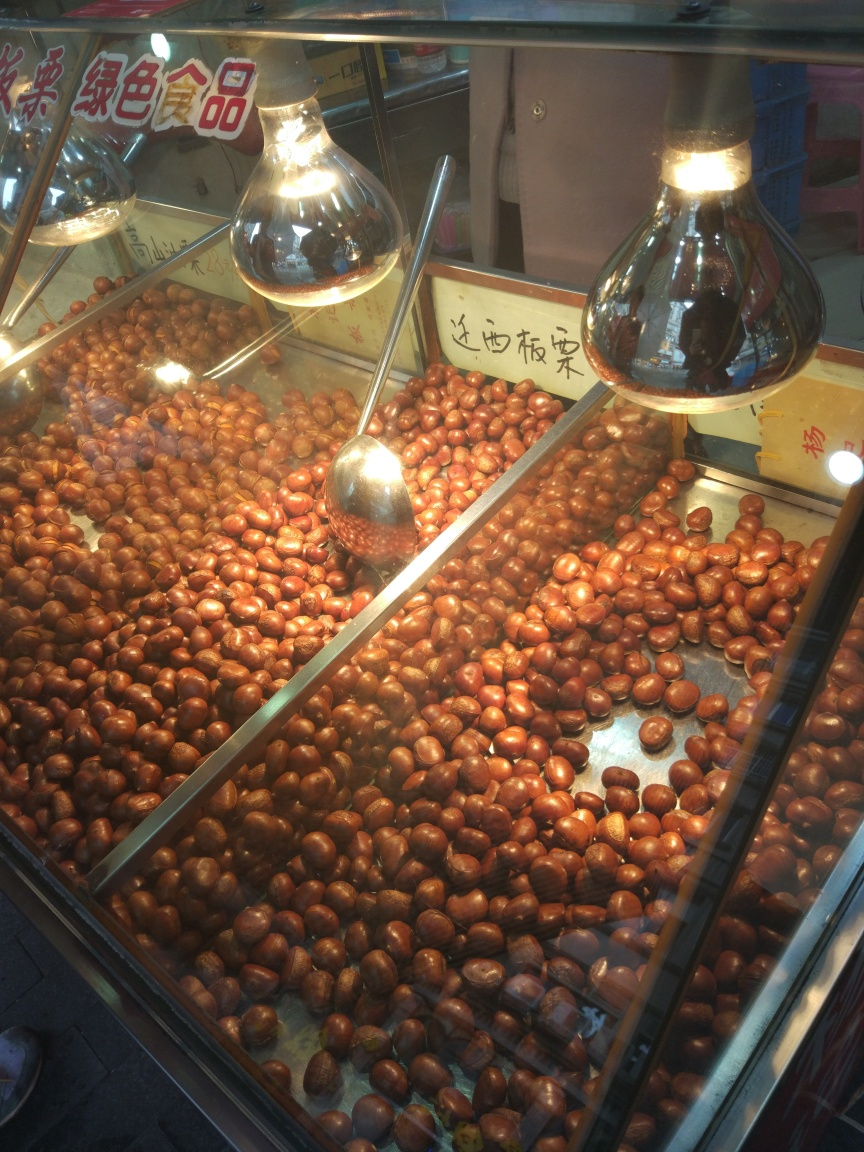Is the text clear and readable?
A. No
B. Yes
Answer with the option's letter from the given choices directly. B. Yes, the text in the image is clear and readable. It displays two words in a script that seems to be Chinese, likely indicating the type of goods or the price, typically found in a food stall or market setting. 